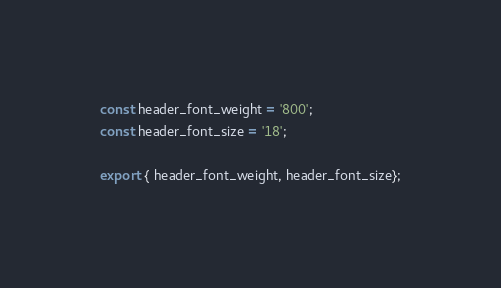<code> <loc_0><loc_0><loc_500><loc_500><_JavaScript_>const header_font_weight = '800';
const header_font_size = '18';

export { header_font_weight, header_font_size};
</code> 